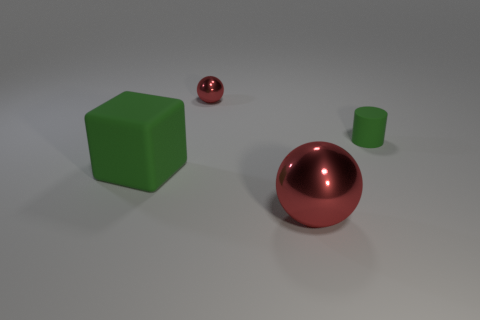What number of spheres are either big green objects or big metal things?
Your response must be concise. 1. Are there the same number of small green rubber cylinders behind the small metal thing and tiny red shiny objects that are right of the cylinder?
Provide a succinct answer. Yes. How many objects are right of the red sphere in front of the small metal thing on the left side of the large shiny ball?
Make the answer very short. 1. There is a object that is the same color as the small metal sphere; what shape is it?
Make the answer very short. Sphere. Do the big rubber block and the metallic ball that is in front of the big green matte object have the same color?
Keep it short and to the point. No. Are there more small green cylinders that are left of the small red metal sphere than red spheres?
Make the answer very short. No. How many objects are red metal balls that are in front of the small cylinder or red things that are in front of the tiny rubber cylinder?
Your answer should be compact. 1. What size is the cylinder that is made of the same material as the big block?
Your response must be concise. Small. Do the rubber object that is in front of the small green object and the tiny metallic thing have the same shape?
Keep it short and to the point. No. What size is the other metal ball that is the same color as the big sphere?
Offer a terse response. Small. 